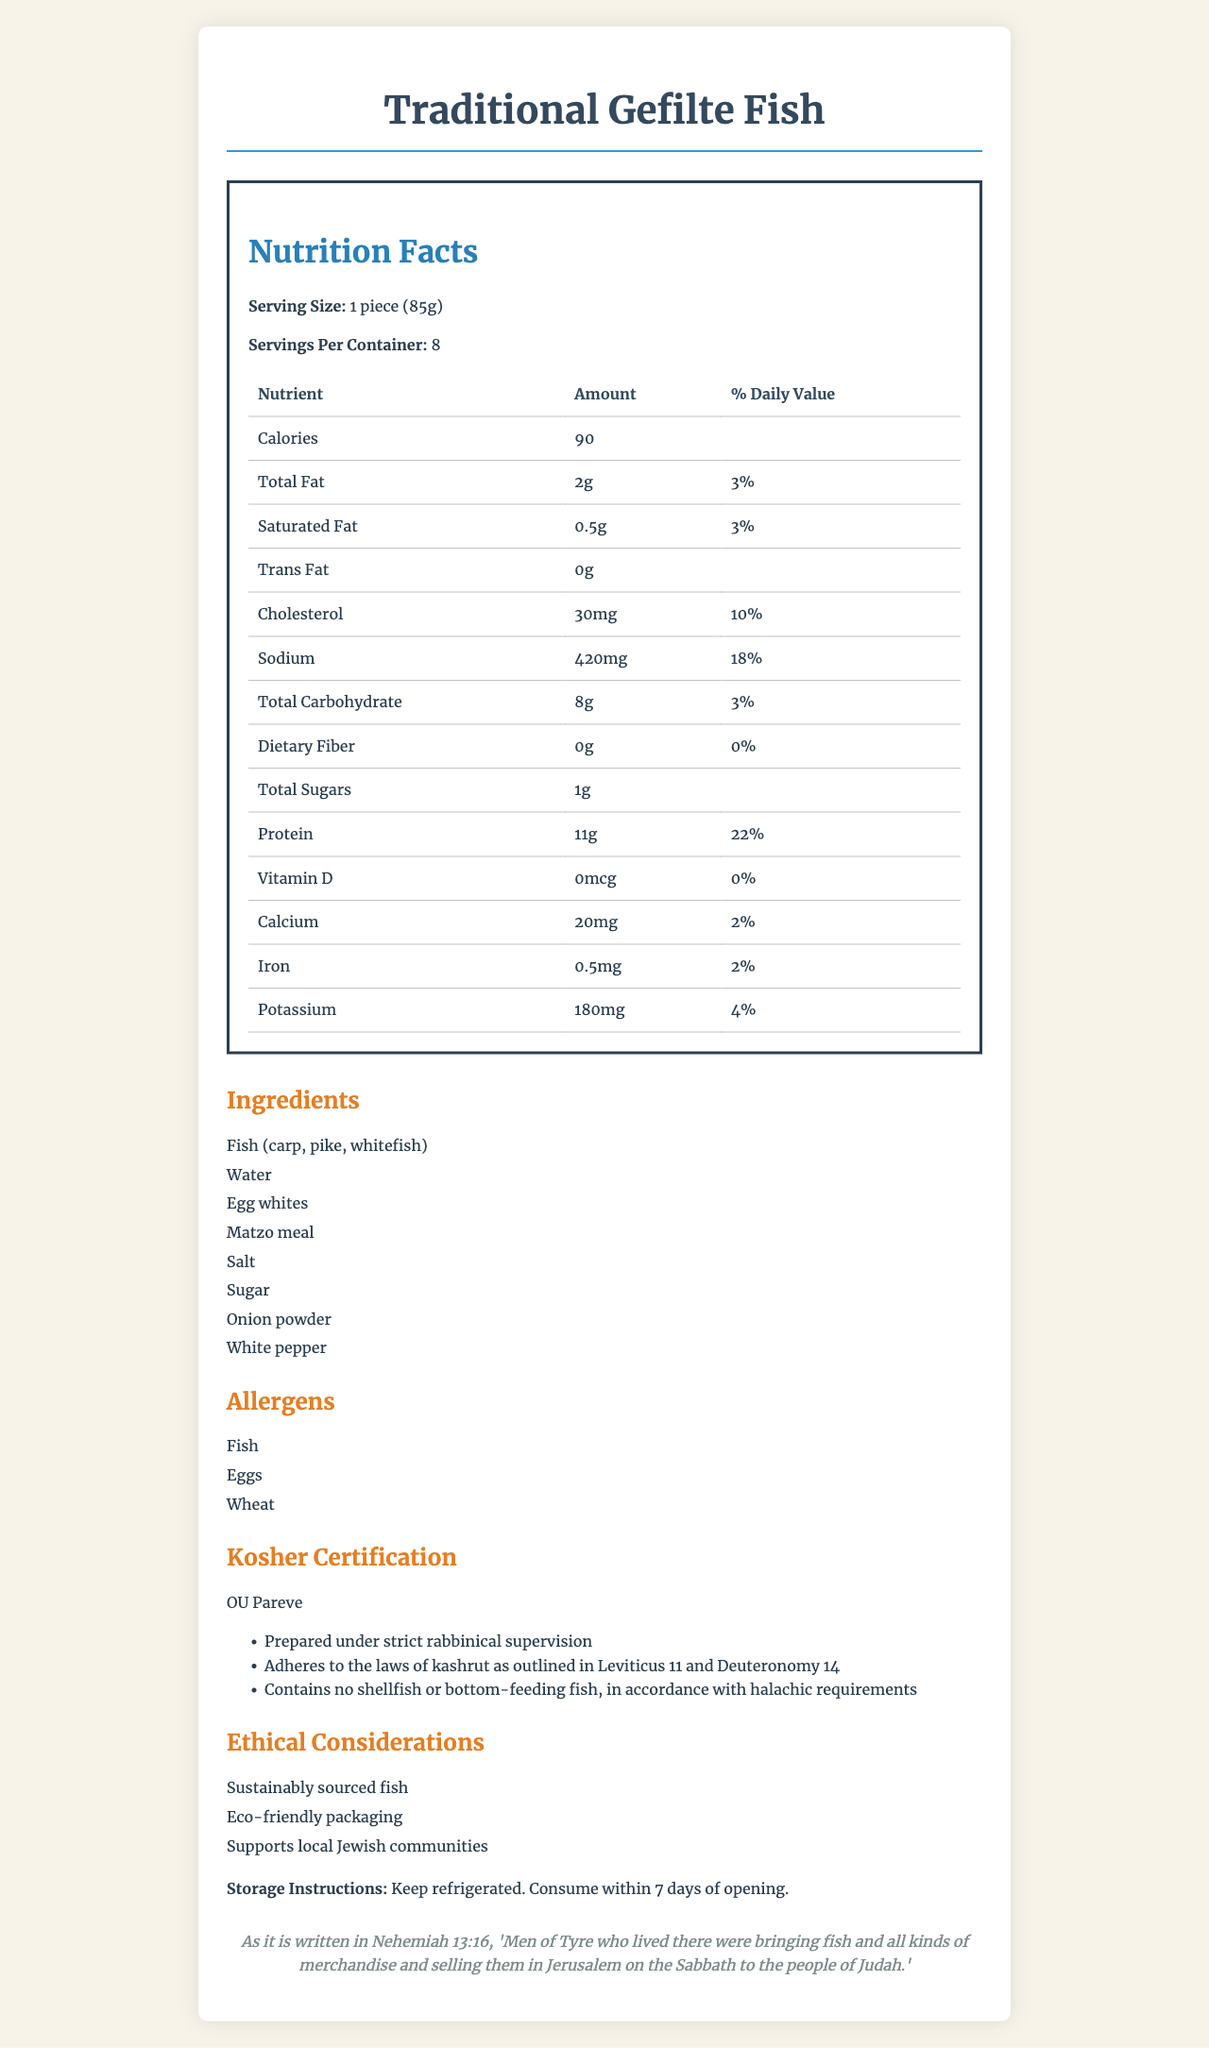what is the serving size for Traditional Gefilte Fish? The serving size is explicitly mentioned as "1 piece (85g)" in the document.
Answer: 1 piece (85g) how many servings are there per container? The document states that there are 8 servings per container.
Answer: 8 how much cholesterol does one serving contain? The nutrition facts table lists "Cholesterol" as 30mg per serving.
Answer: 30mg is this gefilte fish kosher? The document specifies that the product has an "OU Pareve" kosher certification.
Answer: Yes what is the total carbohydrate content per serving? According to the nutrition facts, the total carbohydrate content per serving is 8g.
Answer: 8g how much protein is in each serving? The nutrition facts indicate that each serving contains 11g of protein.
Answer: 11g which organization certified this gefilte fish as kosher? A. OK B. OU C. Kof-K D. Star K The document mentions "OU Pareve" as the kosher certification.
Answer: B what allergens are present in this product? A. Nuts, Dairy B. Fish, Eggs, Wheat C. Soy, Dairy, Nuts The allergens listed are "Fish, Eggs, Wheat".
Answer: B does this product contain any dietary fiber? The document states "Dietary Fiber: 0g", indicating no dietary fiber is present.
Answer: No what is one ethical consideration mentioned for this product? One of the ethical considerations listed is "Sustainably sourced fish".
Answer: Sustainably sourced fish how many calories are in one serving of Traditional Gefilte Fish? The nutrition facts table lists 90 calories per serving.
Answer: 90 how much sodium does one serving contain? The sodium content per serving is specified as 420mg.
Answer: 420mg what biblical reference is mentioned in the document? The document includes a biblical reference from Nehemiah 13:16.
Answer: Nehemiah 13:16 list the main ingredients in the Traditional Gefilte Fish The ingredients section lists "Fish (carp, pike, whitefish), Water, Egg whites, Matzo meal, Salt, Sugar, Onion powder, White pepper".
Answer: Fish, Water, Egg whites, Matzo meal, Salt, Sugar, Onion powder, White pepper name one of the rabbinical notes about the product One rabbinical note is "Prepared under strict rabbinical supervision".
Answer: Prepared under strict rabbinical supervision does the product contain any trans fat? The document specifies "Trans Fat: 0g".
Answer: No which nutrient has the highest daily value percentage per serving? The protein content per serving has a daily value percentage of 22%, which is the highest among the listed nutrients.
Answer: Protein can we find any information about the product's expiration date? The document does not provide any details regarding the expiration date of the product.
Answer: Not enough information summarize the main idea of the document The document comprehensively covers all relevant aspects of the Traditional Gefilte Fish, including its nutritional content, kosher status, ethical considerations, and more.
Answer: The document provides detailed nutrition facts, ingredients, allergens, kosher certification, rabbinical notes, ethical considerations, storage instructions, and a biblical reference for Traditional Gefilte Fish. 